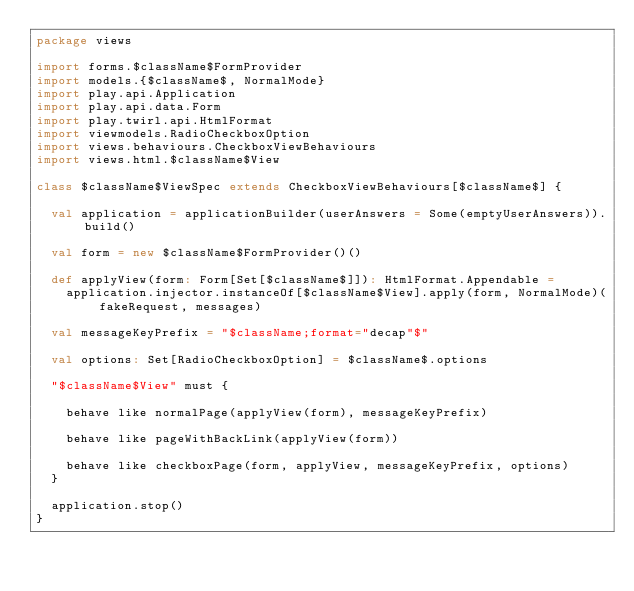<code> <loc_0><loc_0><loc_500><loc_500><_Scala_>package views

import forms.$className$FormProvider
import models.{$className$, NormalMode}
import play.api.Application
import play.api.data.Form
import play.twirl.api.HtmlFormat
import viewmodels.RadioCheckboxOption
import views.behaviours.CheckboxViewBehaviours
import views.html.$className$View

class $className$ViewSpec extends CheckboxViewBehaviours[$className$] {

  val application = applicationBuilder(userAnswers = Some(emptyUserAnswers)).build()

  val form = new $className$FormProvider()()

  def applyView(form: Form[Set[$className$]]): HtmlFormat.Appendable =
    application.injector.instanceOf[$className$View].apply(form, NormalMode)(fakeRequest, messages)

  val messageKeyPrefix = "$className;format="decap"$"

  val options: Set[RadioCheckboxOption] = $className$.options

  "$className$View" must {

    behave like normalPage(applyView(form), messageKeyPrefix)

    behave like pageWithBackLink(applyView(form))

    behave like checkboxPage(form, applyView, messageKeyPrefix, options)
  }

  application.stop()
}
</code> 